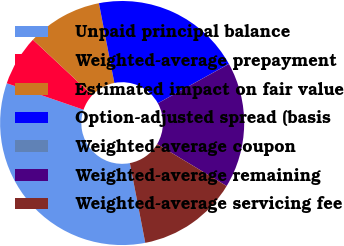Convert chart. <chart><loc_0><loc_0><loc_500><loc_500><pie_chart><fcel>Unpaid principal balance<fcel>Weighted-average prepayment<fcel>Estimated impact on fair value<fcel>Option-adjusted spread (basis<fcel>Weighted-average coupon<fcel>Weighted-average remaining<fcel>Weighted-average servicing fee<nl><fcel>33.32%<fcel>6.67%<fcel>10.0%<fcel>20.0%<fcel>0.01%<fcel>16.67%<fcel>13.33%<nl></chart> 